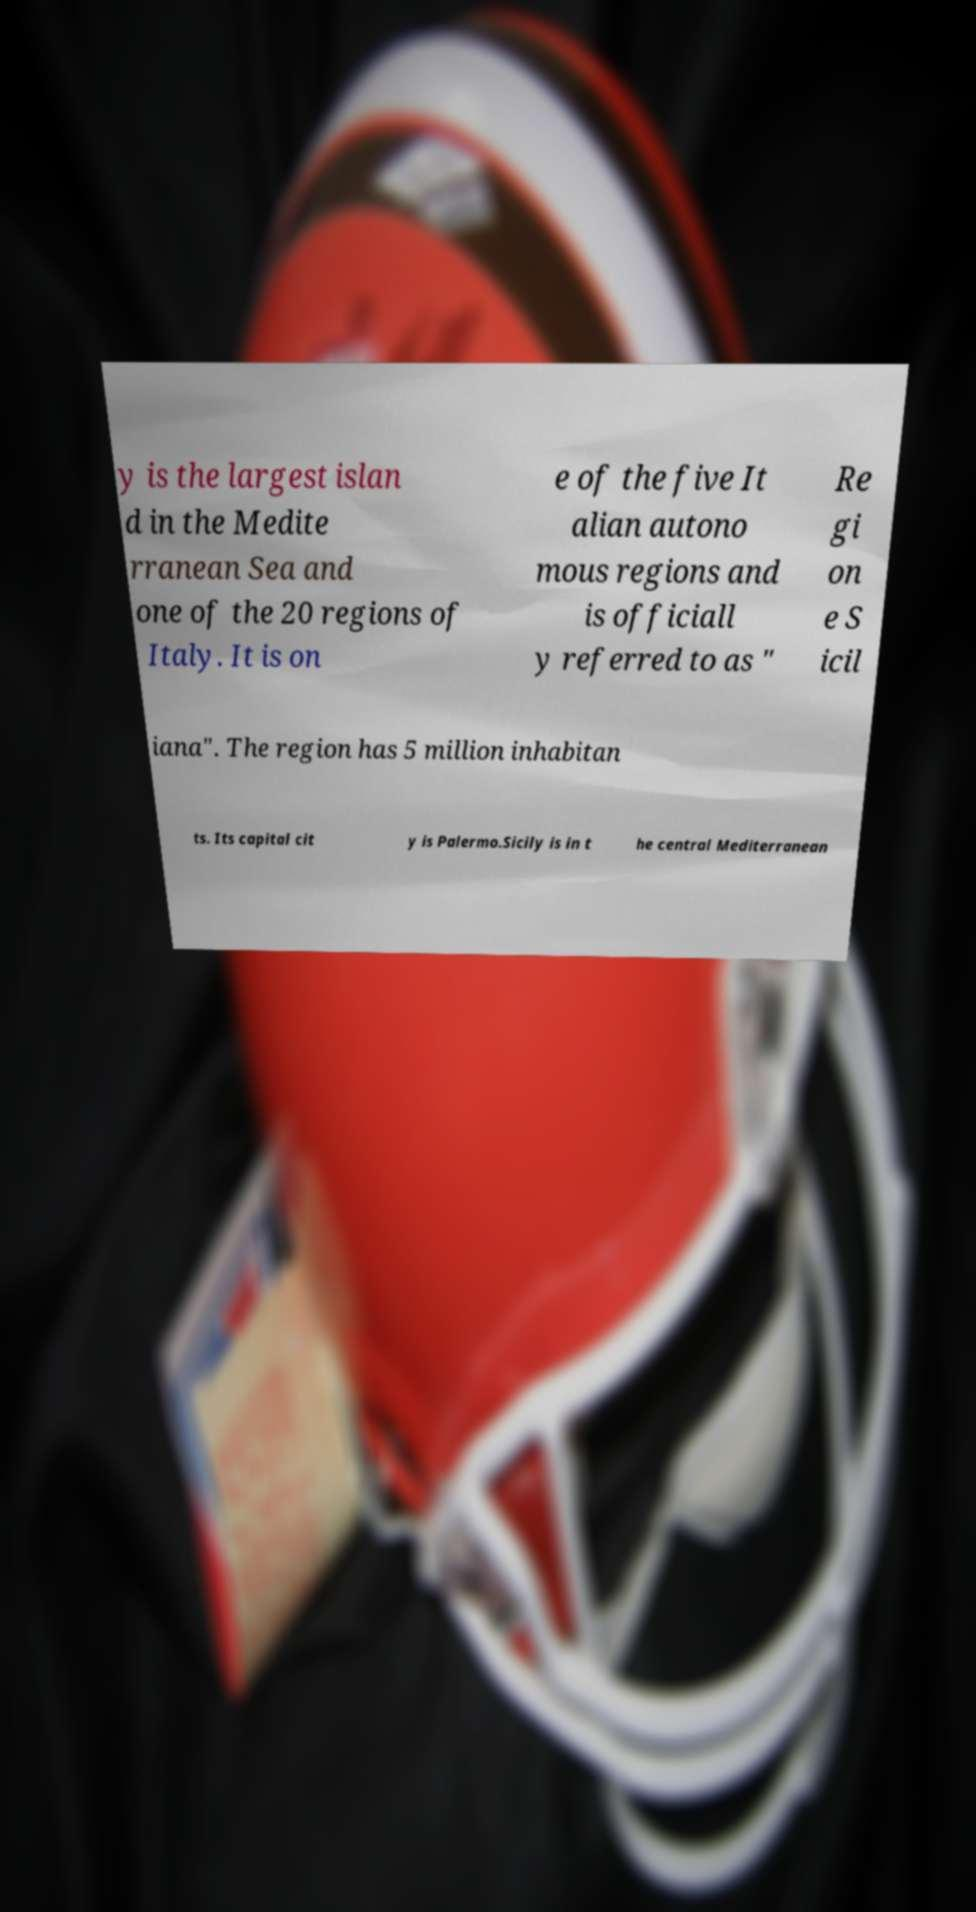I need the written content from this picture converted into text. Can you do that? y is the largest islan d in the Medite rranean Sea and one of the 20 regions of Italy. It is on e of the five It alian autono mous regions and is officiall y referred to as " Re gi on e S icil iana". The region has 5 million inhabitan ts. Its capital cit y is Palermo.Sicily is in t he central Mediterranean 